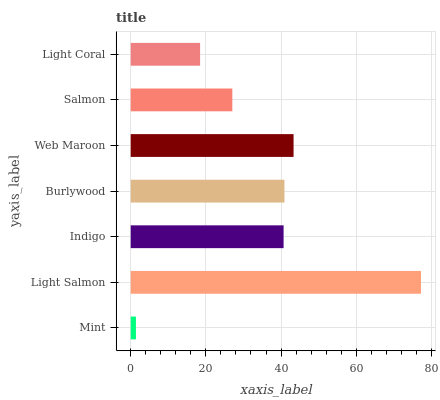Is Mint the minimum?
Answer yes or no. Yes. Is Light Salmon the maximum?
Answer yes or no. Yes. Is Indigo the minimum?
Answer yes or no. No. Is Indigo the maximum?
Answer yes or no. No. Is Light Salmon greater than Indigo?
Answer yes or no. Yes. Is Indigo less than Light Salmon?
Answer yes or no. Yes. Is Indigo greater than Light Salmon?
Answer yes or no. No. Is Light Salmon less than Indigo?
Answer yes or no. No. Is Indigo the high median?
Answer yes or no. Yes. Is Indigo the low median?
Answer yes or no. Yes. Is Light Salmon the high median?
Answer yes or no. No. Is Burlywood the low median?
Answer yes or no. No. 